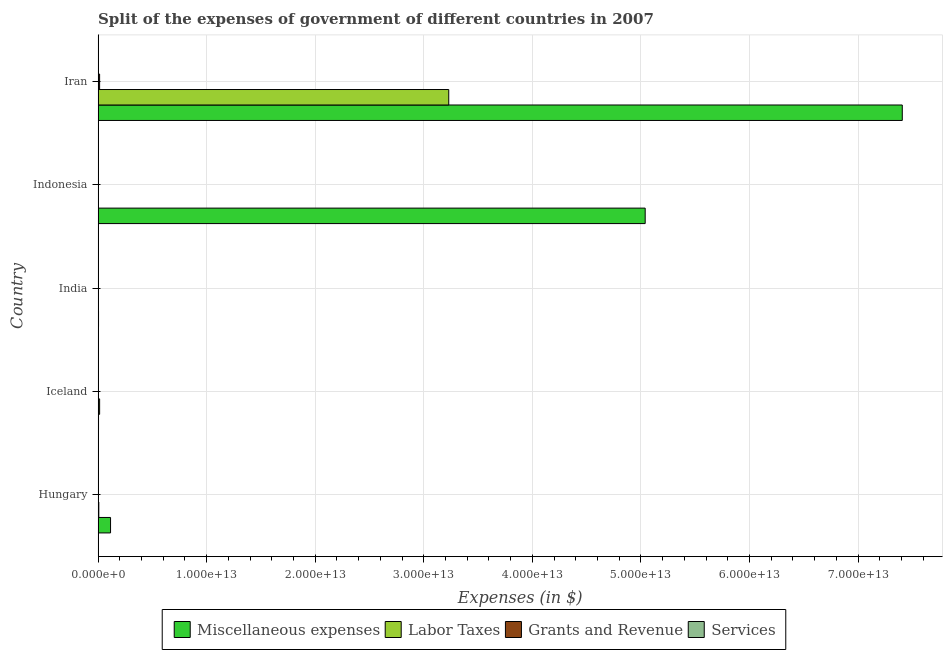Are the number of bars per tick equal to the number of legend labels?
Provide a short and direct response. Yes. How many bars are there on the 5th tick from the top?
Offer a terse response. 4. What is the label of the 4th group of bars from the top?
Ensure brevity in your answer.  Iceland. In how many cases, is the number of bars for a given country not equal to the number of legend labels?
Your response must be concise. 0. What is the amount spent on miscellaneous expenses in Indonesia?
Your answer should be compact. 5.04e+13. Across all countries, what is the maximum amount spent on miscellaneous expenses?
Give a very brief answer. 7.41e+13. Across all countries, what is the minimum amount spent on grants and revenue?
Ensure brevity in your answer.  4.55e+07. What is the total amount spent on miscellaneous expenses in the graph?
Make the answer very short. 1.26e+14. What is the difference between the amount spent on labor taxes in Hungary and that in Indonesia?
Provide a short and direct response. 6.00e+1. What is the difference between the amount spent on services in Iran and the amount spent on labor taxes in India?
Provide a succinct answer. -4.79e+09. What is the average amount spent on miscellaneous expenses per country?
Make the answer very short. 2.51e+13. What is the difference between the amount spent on labor taxes and amount spent on services in Indonesia?
Offer a very short reply. 9.53e+08. What is the ratio of the amount spent on grants and revenue in Iceland to that in India?
Your answer should be very brief. 0.04. Is the difference between the amount spent on services in Hungary and India greater than the difference between the amount spent on grants and revenue in Hungary and India?
Provide a short and direct response. No. What is the difference between the highest and the second highest amount spent on grants and revenue?
Provide a short and direct response. 1.25e+11. What is the difference between the highest and the lowest amount spent on labor taxes?
Make the answer very short. 3.23e+13. Is it the case that in every country, the sum of the amount spent on labor taxes and amount spent on services is greater than the sum of amount spent on miscellaneous expenses and amount spent on grants and revenue?
Your answer should be very brief. No. What does the 2nd bar from the top in Indonesia represents?
Your answer should be compact. Grants and Revenue. What does the 3rd bar from the bottom in Indonesia represents?
Your response must be concise. Grants and Revenue. How many countries are there in the graph?
Your response must be concise. 5. What is the difference between two consecutive major ticks on the X-axis?
Your answer should be very brief. 1.00e+13. Does the graph contain any zero values?
Give a very brief answer. No. Where does the legend appear in the graph?
Offer a terse response. Bottom center. How many legend labels are there?
Keep it short and to the point. 4. How are the legend labels stacked?
Keep it short and to the point. Horizontal. What is the title of the graph?
Provide a short and direct response. Split of the expenses of government of different countries in 2007. What is the label or title of the X-axis?
Your answer should be compact. Expenses (in $). What is the label or title of the Y-axis?
Make the answer very short. Country. What is the Expenses (in $) in Miscellaneous expenses in Hungary?
Your answer should be compact. 1.15e+12. What is the Expenses (in $) in Labor Taxes in Hungary?
Ensure brevity in your answer.  6.44e+1. What is the Expenses (in $) in Grants and Revenue in Hungary?
Ensure brevity in your answer.  1.34e+1. What is the Expenses (in $) in Services in Hungary?
Offer a very short reply. 6.16e+08. What is the Expenses (in $) in Miscellaneous expenses in Iceland?
Ensure brevity in your answer.  3.76e+1. What is the Expenses (in $) in Labor Taxes in Iceland?
Offer a terse response. 1.38e+11. What is the Expenses (in $) in Grants and Revenue in Iceland?
Ensure brevity in your answer.  4.55e+07. What is the Expenses (in $) in Services in Iceland?
Keep it short and to the point. 1.35e+1. What is the Expenses (in $) in Miscellaneous expenses in India?
Provide a succinct answer. 3.86e+1. What is the Expenses (in $) in Labor Taxes in India?
Your response must be concise. 1.35e+1. What is the Expenses (in $) in Grants and Revenue in India?
Keep it short and to the point. 1.30e+09. What is the Expenses (in $) in Services in India?
Make the answer very short. 7.91e+07. What is the Expenses (in $) in Miscellaneous expenses in Indonesia?
Your response must be concise. 5.04e+13. What is the Expenses (in $) of Labor Taxes in Indonesia?
Make the answer very short. 4.40e+09. What is the Expenses (in $) of Grants and Revenue in Indonesia?
Provide a succinct answer. 1.09e+1. What is the Expenses (in $) in Services in Indonesia?
Your response must be concise. 3.45e+09. What is the Expenses (in $) in Miscellaneous expenses in Iran?
Your answer should be very brief. 7.41e+13. What is the Expenses (in $) in Labor Taxes in Iran?
Make the answer very short. 3.23e+13. What is the Expenses (in $) of Grants and Revenue in Iran?
Offer a very short reply. 1.38e+11. What is the Expenses (in $) of Services in Iran?
Keep it short and to the point. 8.74e+09. Across all countries, what is the maximum Expenses (in $) in Miscellaneous expenses?
Offer a very short reply. 7.41e+13. Across all countries, what is the maximum Expenses (in $) of Labor Taxes?
Your response must be concise. 3.23e+13. Across all countries, what is the maximum Expenses (in $) in Grants and Revenue?
Your response must be concise. 1.38e+11. Across all countries, what is the maximum Expenses (in $) in Services?
Make the answer very short. 1.35e+1. Across all countries, what is the minimum Expenses (in $) of Miscellaneous expenses?
Your answer should be very brief. 3.76e+1. Across all countries, what is the minimum Expenses (in $) in Labor Taxes?
Your answer should be very brief. 4.40e+09. Across all countries, what is the minimum Expenses (in $) of Grants and Revenue?
Offer a very short reply. 4.55e+07. Across all countries, what is the minimum Expenses (in $) in Services?
Your answer should be very brief. 7.91e+07. What is the total Expenses (in $) in Miscellaneous expenses in the graph?
Your answer should be compact. 1.26e+14. What is the total Expenses (in $) of Labor Taxes in the graph?
Give a very brief answer. 3.25e+13. What is the total Expenses (in $) of Grants and Revenue in the graph?
Your answer should be compact. 1.64e+11. What is the total Expenses (in $) of Services in the graph?
Provide a succinct answer. 2.64e+1. What is the difference between the Expenses (in $) of Miscellaneous expenses in Hungary and that in Iceland?
Your response must be concise. 1.11e+12. What is the difference between the Expenses (in $) in Labor Taxes in Hungary and that in Iceland?
Your answer should be very brief. -7.39e+1. What is the difference between the Expenses (in $) of Grants and Revenue in Hungary and that in Iceland?
Make the answer very short. 1.33e+1. What is the difference between the Expenses (in $) in Services in Hungary and that in Iceland?
Provide a succinct answer. -1.29e+1. What is the difference between the Expenses (in $) in Miscellaneous expenses in Hungary and that in India?
Give a very brief answer. 1.11e+12. What is the difference between the Expenses (in $) of Labor Taxes in Hungary and that in India?
Your response must be concise. 5.09e+1. What is the difference between the Expenses (in $) of Grants and Revenue in Hungary and that in India?
Offer a very short reply. 1.21e+1. What is the difference between the Expenses (in $) of Services in Hungary and that in India?
Your response must be concise. 5.37e+08. What is the difference between the Expenses (in $) in Miscellaneous expenses in Hungary and that in Indonesia?
Provide a succinct answer. -4.92e+13. What is the difference between the Expenses (in $) of Labor Taxes in Hungary and that in Indonesia?
Give a very brief answer. 6.00e+1. What is the difference between the Expenses (in $) in Grants and Revenue in Hungary and that in Indonesia?
Ensure brevity in your answer.  2.43e+09. What is the difference between the Expenses (in $) in Services in Hungary and that in Indonesia?
Provide a short and direct response. -2.83e+09. What is the difference between the Expenses (in $) in Miscellaneous expenses in Hungary and that in Iran?
Provide a succinct answer. -7.29e+13. What is the difference between the Expenses (in $) of Labor Taxes in Hungary and that in Iran?
Make the answer very short. -3.22e+13. What is the difference between the Expenses (in $) in Grants and Revenue in Hungary and that in Iran?
Offer a terse response. -1.25e+11. What is the difference between the Expenses (in $) in Services in Hungary and that in Iran?
Make the answer very short. -8.12e+09. What is the difference between the Expenses (in $) in Miscellaneous expenses in Iceland and that in India?
Offer a terse response. -9.79e+08. What is the difference between the Expenses (in $) in Labor Taxes in Iceland and that in India?
Your answer should be very brief. 1.25e+11. What is the difference between the Expenses (in $) of Grants and Revenue in Iceland and that in India?
Provide a succinct answer. -1.25e+09. What is the difference between the Expenses (in $) of Services in Iceland and that in India?
Your response must be concise. 1.34e+1. What is the difference between the Expenses (in $) in Miscellaneous expenses in Iceland and that in Indonesia?
Keep it short and to the point. -5.04e+13. What is the difference between the Expenses (in $) in Labor Taxes in Iceland and that in Indonesia?
Ensure brevity in your answer.  1.34e+11. What is the difference between the Expenses (in $) of Grants and Revenue in Iceland and that in Indonesia?
Your response must be concise. -1.09e+1. What is the difference between the Expenses (in $) of Services in Iceland and that in Indonesia?
Provide a succinct answer. 1.00e+1. What is the difference between the Expenses (in $) in Miscellaneous expenses in Iceland and that in Iran?
Provide a short and direct response. -7.40e+13. What is the difference between the Expenses (in $) in Labor Taxes in Iceland and that in Iran?
Your answer should be compact. -3.22e+13. What is the difference between the Expenses (in $) of Grants and Revenue in Iceland and that in Iran?
Provide a succinct answer. -1.38e+11. What is the difference between the Expenses (in $) in Services in Iceland and that in Iran?
Your answer should be compact. 4.73e+09. What is the difference between the Expenses (in $) in Miscellaneous expenses in India and that in Indonesia?
Make the answer very short. -5.04e+13. What is the difference between the Expenses (in $) of Labor Taxes in India and that in Indonesia?
Your response must be concise. 9.12e+09. What is the difference between the Expenses (in $) in Grants and Revenue in India and that in Indonesia?
Your answer should be very brief. -9.64e+09. What is the difference between the Expenses (in $) in Services in India and that in Indonesia?
Give a very brief answer. -3.37e+09. What is the difference between the Expenses (in $) of Miscellaneous expenses in India and that in Iran?
Ensure brevity in your answer.  -7.40e+13. What is the difference between the Expenses (in $) of Labor Taxes in India and that in Iran?
Your answer should be compact. -3.23e+13. What is the difference between the Expenses (in $) of Grants and Revenue in India and that in Iran?
Make the answer very short. -1.37e+11. What is the difference between the Expenses (in $) in Services in India and that in Iran?
Provide a short and direct response. -8.66e+09. What is the difference between the Expenses (in $) in Miscellaneous expenses in Indonesia and that in Iran?
Ensure brevity in your answer.  -2.37e+13. What is the difference between the Expenses (in $) of Labor Taxes in Indonesia and that in Iran?
Offer a terse response. -3.23e+13. What is the difference between the Expenses (in $) in Grants and Revenue in Indonesia and that in Iran?
Provide a succinct answer. -1.27e+11. What is the difference between the Expenses (in $) of Services in Indonesia and that in Iran?
Your answer should be compact. -5.29e+09. What is the difference between the Expenses (in $) of Miscellaneous expenses in Hungary and the Expenses (in $) of Labor Taxes in Iceland?
Provide a succinct answer. 1.01e+12. What is the difference between the Expenses (in $) of Miscellaneous expenses in Hungary and the Expenses (in $) of Grants and Revenue in Iceland?
Your response must be concise. 1.15e+12. What is the difference between the Expenses (in $) of Miscellaneous expenses in Hungary and the Expenses (in $) of Services in Iceland?
Give a very brief answer. 1.13e+12. What is the difference between the Expenses (in $) in Labor Taxes in Hungary and the Expenses (in $) in Grants and Revenue in Iceland?
Your response must be concise. 6.43e+1. What is the difference between the Expenses (in $) in Labor Taxes in Hungary and the Expenses (in $) in Services in Iceland?
Give a very brief answer. 5.09e+1. What is the difference between the Expenses (in $) in Grants and Revenue in Hungary and the Expenses (in $) in Services in Iceland?
Keep it short and to the point. -1.08e+08. What is the difference between the Expenses (in $) of Miscellaneous expenses in Hungary and the Expenses (in $) of Labor Taxes in India?
Provide a short and direct response. 1.13e+12. What is the difference between the Expenses (in $) of Miscellaneous expenses in Hungary and the Expenses (in $) of Grants and Revenue in India?
Ensure brevity in your answer.  1.14e+12. What is the difference between the Expenses (in $) of Miscellaneous expenses in Hungary and the Expenses (in $) of Services in India?
Your answer should be compact. 1.15e+12. What is the difference between the Expenses (in $) of Labor Taxes in Hungary and the Expenses (in $) of Grants and Revenue in India?
Your answer should be very brief. 6.31e+1. What is the difference between the Expenses (in $) of Labor Taxes in Hungary and the Expenses (in $) of Services in India?
Keep it short and to the point. 6.43e+1. What is the difference between the Expenses (in $) of Grants and Revenue in Hungary and the Expenses (in $) of Services in India?
Your response must be concise. 1.33e+1. What is the difference between the Expenses (in $) in Miscellaneous expenses in Hungary and the Expenses (in $) in Labor Taxes in Indonesia?
Provide a succinct answer. 1.14e+12. What is the difference between the Expenses (in $) of Miscellaneous expenses in Hungary and the Expenses (in $) of Grants and Revenue in Indonesia?
Keep it short and to the point. 1.13e+12. What is the difference between the Expenses (in $) in Miscellaneous expenses in Hungary and the Expenses (in $) in Services in Indonesia?
Your answer should be compact. 1.14e+12. What is the difference between the Expenses (in $) of Labor Taxes in Hungary and the Expenses (in $) of Grants and Revenue in Indonesia?
Make the answer very short. 5.35e+1. What is the difference between the Expenses (in $) in Labor Taxes in Hungary and the Expenses (in $) in Services in Indonesia?
Your response must be concise. 6.09e+1. What is the difference between the Expenses (in $) of Grants and Revenue in Hungary and the Expenses (in $) of Services in Indonesia?
Ensure brevity in your answer.  9.91e+09. What is the difference between the Expenses (in $) in Miscellaneous expenses in Hungary and the Expenses (in $) in Labor Taxes in Iran?
Offer a terse response. -3.12e+13. What is the difference between the Expenses (in $) in Miscellaneous expenses in Hungary and the Expenses (in $) in Grants and Revenue in Iran?
Your answer should be compact. 1.01e+12. What is the difference between the Expenses (in $) in Miscellaneous expenses in Hungary and the Expenses (in $) in Services in Iran?
Offer a terse response. 1.14e+12. What is the difference between the Expenses (in $) of Labor Taxes in Hungary and the Expenses (in $) of Grants and Revenue in Iran?
Your response must be concise. -7.37e+1. What is the difference between the Expenses (in $) of Labor Taxes in Hungary and the Expenses (in $) of Services in Iran?
Give a very brief answer. 5.57e+1. What is the difference between the Expenses (in $) in Grants and Revenue in Hungary and the Expenses (in $) in Services in Iran?
Make the answer very short. 4.62e+09. What is the difference between the Expenses (in $) in Miscellaneous expenses in Iceland and the Expenses (in $) in Labor Taxes in India?
Provide a short and direct response. 2.40e+1. What is the difference between the Expenses (in $) in Miscellaneous expenses in Iceland and the Expenses (in $) in Grants and Revenue in India?
Give a very brief answer. 3.63e+1. What is the difference between the Expenses (in $) of Miscellaneous expenses in Iceland and the Expenses (in $) of Services in India?
Your answer should be very brief. 3.75e+1. What is the difference between the Expenses (in $) in Labor Taxes in Iceland and the Expenses (in $) in Grants and Revenue in India?
Offer a terse response. 1.37e+11. What is the difference between the Expenses (in $) in Labor Taxes in Iceland and the Expenses (in $) in Services in India?
Keep it short and to the point. 1.38e+11. What is the difference between the Expenses (in $) of Grants and Revenue in Iceland and the Expenses (in $) of Services in India?
Offer a terse response. -3.36e+07. What is the difference between the Expenses (in $) in Miscellaneous expenses in Iceland and the Expenses (in $) in Labor Taxes in Indonesia?
Offer a very short reply. 3.32e+1. What is the difference between the Expenses (in $) of Miscellaneous expenses in Iceland and the Expenses (in $) of Grants and Revenue in Indonesia?
Make the answer very short. 2.66e+1. What is the difference between the Expenses (in $) of Miscellaneous expenses in Iceland and the Expenses (in $) of Services in Indonesia?
Make the answer very short. 3.41e+1. What is the difference between the Expenses (in $) of Labor Taxes in Iceland and the Expenses (in $) of Grants and Revenue in Indonesia?
Provide a short and direct response. 1.27e+11. What is the difference between the Expenses (in $) of Labor Taxes in Iceland and the Expenses (in $) of Services in Indonesia?
Offer a terse response. 1.35e+11. What is the difference between the Expenses (in $) in Grants and Revenue in Iceland and the Expenses (in $) in Services in Indonesia?
Your response must be concise. -3.40e+09. What is the difference between the Expenses (in $) of Miscellaneous expenses in Iceland and the Expenses (in $) of Labor Taxes in Iran?
Offer a terse response. -3.23e+13. What is the difference between the Expenses (in $) in Miscellaneous expenses in Iceland and the Expenses (in $) in Grants and Revenue in Iran?
Ensure brevity in your answer.  -1.01e+11. What is the difference between the Expenses (in $) of Miscellaneous expenses in Iceland and the Expenses (in $) of Services in Iran?
Your answer should be very brief. 2.88e+1. What is the difference between the Expenses (in $) in Labor Taxes in Iceland and the Expenses (in $) in Grants and Revenue in Iran?
Make the answer very short. 2.32e+08. What is the difference between the Expenses (in $) of Labor Taxes in Iceland and the Expenses (in $) of Services in Iran?
Make the answer very short. 1.30e+11. What is the difference between the Expenses (in $) of Grants and Revenue in Iceland and the Expenses (in $) of Services in Iran?
Give a very brief answer. -8.69e+09. What is the difference between the Expenses (in $) of Miscellaneous expenses in India and the Expenses (in $) of Labor Taxes in Indonesia?
Offer a very short reply. 3.42e+1. What is the difference between the Expenses (in $) in Miscellaneous expenses in India and the Expenses (in $) in Grants and Revenue in Indonesia?
Your answer should be compact. 2.76e+1. What is the difference between the Expenses (in $) of Miscellaneous expenses in India and the Expenses (in $) of Services in Indonesia?
Ensure brevity in your answer.  3.51e+1. What is the difference between the Expenses (in $) in Labor Taxes in India and the Expenses (in $) in Grants and Revenue in Indonesia?
Keep it short and to the point. 2.59e+09. What is the difference between the Expenses (in $) of Labor Taxes in India and the Expenses (in $) of Services in Indonesia?
Offer a terse response. 1.01e+1. What is the difference between the Expenses (in $) of Grants and Revenue in India and the Expenses (in $) of Services in Indonesia?
Offer a terse response. -2.15e+09. What is the difference between the Expenses (in $) of Miscellaneous expenses in India and the Expenses (in $) of Labor Taxes in Iran?
Keep it short and to the point. -3.23e+13. What is the difference between the Expenses (in $) in Miscellaneous expenses in India and the Expenses (in $) in Grants and Revenue in Iran?
Your response must be concise. -9.95e+1. What is the difference between the Expenses (in $) of Miscellaneous expenses in India and the Expenses (in $) of Services in Iran?
Your response must be concise. 2.98e+1. What is the difference between the Expenses (in $) in Labor Taxes in India and the Expenses (in $) in Grants and Revenue in Iran?
Give a very brief answer. -1.25e+11. What is the difference between the Expenses (in $) of Labor Taxes in India and the Expenses (in $) of Services in Iran?
Your answer should be very brief. 4.79e+09. What is the difference between the Expenses (in $) in Grants and Revenue in India and the Expenses (in $) in Services in Iran?
Keep it short and to the point. -7.44e+09. What is the difference between the Expenses (in $) in Miscellaneous expenses in Indonesia and the Expenses (in $) in Labor Taxes in Iran?
Provide a short and direct response. 1.81e+13. What is the difference between the Expenses (in $) in Miscellaneous expenses in Indonesia and the Expenses (in $) in Grants and Revenue in Iran?
Your answer should be very brief. 5.03e+13. What is the difference between the Expenses (in $) of Miscellaneous expenses in Indonesia and the Expenses (in $) of Services in Iran?
Ensure brevity in your answer.  5.04e+13. What is the difference between the Expenses (in $) in Labor Taxes in Indonesia and the Expenses (in $) in Grants and Revenue in Iran?
Give a very brief answer. -1.34e+11. What is the difference between the Expenses (in $) of Labor Taxes in Indonesia and the Expenses (in $) of Services in Iran?
Provide a short and direct response. -4.34e+09. What is the difference between the Expenses (in $) in Grants and Revenue in Indonesia and the Expenses (in $) in Services in Iran?
Keep it short and to the point. 2.19e+09. What is the average Expenses (in $) in Miscellaneous expenses per country?
Make the answer very short. 2.51e+13. What is the average Expenses (in $) in Labor Taxes per country?
Make the answer very short. 6.50e+12. What is the average Expenses (in $) in Grants and Revenue per country?
Offer a very short reply. 3.27e+1. What is the average Expenses (in $) of Services per country?
Make the answer very short. 5.27e+09. What is the difference between the Expenses (in $) of Miscellaneous expenses and Expenses (in $) of Labor Taxes in Hungary?
Your answer should be very brief. 1.08e+12. What is the difference between the Expenses (in $) of Miscellaneous expenses and Expenses (in $) of Grants and Revenue in Hungary?
Ensure brevity in your answer.  1.13e+12. What is the difference between the Expenses (in $) in Miscellaneous expenses and Expenses (in $) in Services in Hungary?
Offer a very short reply. 1.14e+12. What is the difference between the Expenses (in $) of Labor Taxes and Expenses (in $) of Grants and Revenue in Hungary?
Make the answer very short. 5.10e+1. What is the difference between the Expenses (in $) of Labor Taxes and Expenses (in $) of Services in Hungary?
Your response must be concise. 6.38e+1. What is the difference between the Expenses (in $) in Grants and Revenue and Expenses (in $) in Services in Hungary?
Provide a succinct answer. 1.27e+1. What is the difference between the Expenses (in $) of Miscellaneous expenses and Expenses (in $) of Labor Taxes in Iceland?
Your answer should be compact. -1.01e+11. What is the difference between the Expenses (in $) in Miscellaneous expenses and Expenses (in $) in Grants and Revenue in Iceland?
Your response must be concise. 3.75e+1. What is the difference between the Expenses (in $) in Miscellaneous expenses and Expenses (in $) in Services in Iceland?
Give a very brief answer. 2.41e+1. What is the difference between the Expenses (in $) in Labor Taxes and Expenses (in $) in Grants and Revenue in Iceland?
Ensure brevity in your answer.  1.38e+11. What is the difference between the Expenses (in $) in Labor Taxes and Expenses (in $) in Services in Iceland?
Provide a succinct answer. 1.25e+11. What is the difference between the Expenses (in $) in Grants and Revenue and Expenses (in $) in Services in Iceland?
Provide a succinct answer. -1.34e+1. What is the difference between the Expenses (in $) of Miscellaneous expenses and Expenses (in $) of Labor Taxes in India?
Ensure brevity in your answer.  2.50e+1. What is the difference between the Expenses (in $) in Miscellaneous expenses and Expenses (in $) in Grants and Revenue in India?
Give a very brief answer. 3.73e+1. What is the difference between the Expenses (in $) of Miscellaneous expenses and Expenses (in $) of Services in India?
Keep it short and to the point. 3.85e+1. What is the difference between the Expenses (in $) of Labor Taxes and Expenses (in $) of Grants and Revenue in India?
Provide a succinct answer. 1.22e+1. What is the difference between the Expenses (in $) in Labor Taxes and Expenses (in $) in Services in India?
Offer a very short reply. 1.34e+1. What is the difference between the Expenses (in $) of Grants and Revenue and Expenses (in $) of Services in India?
Provide a succinct answer. 1.22e+09. What is the difference between the Expenses (in $) of Miscellaneous expenses and Expenses (in $) of Labor Taxes in Indonesia?
Provide a short and direct response. 5.04e+13. What is the difference between the Expenses (in $) of Miscellaneous expenses and Expenses (in $) of Grants and Revenue in Indonesia?
Your answer should be very brief. 5.04e+13. What is the difference between the Expenses (in $) of Miscellaneous expenses and Expenses (in $) of Services in Indonesia?
Ensure brevity in your answer.  5.04e+13. What is the difference between the Expenses (in $) in Labor Taxes and Expenses (in $) in Grants and Revenue in Indonesia?
Your answer should be compact. -6.53e+09. What is the difference between the Expenses (in $) of Labor Taxes and Expenses (in $) of Services in Indonesia?
Provide a succinct answer. 9.53e+08. What is the difference between the Expenses (in $) in Grants and Revenue and Expenses (in $) in Services in Indonesia?
Provide a succinct answer. 7.48e+09. What is the difference between the Expenses (in $) in Miscellaneous expenses and Expenses (in $) in Labor Taxes in Iran?
Your response must be concise. 4.18e+13. What is the difference between the Expenses (in $) in Miscellaneous expenses and Expenses (in $) in Grants and Revenue in Iran?
Your response must be concise. 7.39e+13. What is the difference between the Expenses (in $) of Miscellaneous expenses and Expenses (in $) of Services in Iran?
Make the answer very short. 7.41e+13. What is the difference between the Expenses (in $) of Labor Taxes and Expenses (in $) of Grants and Revenue in Iran?
Offer a very short reply. 3.22e+13. What is the difference between the Expenses (in $) of Labor Taxes and Expenses (in $) of Services in Iran?
Give a very brief answer. 3.23e+13. What is the difference between the Expenses (in $) of Grants and Revenue and Expenses (in $) of Services in Iran?
Your answer should be compact. 1.29e+11. What is the ratio of the Expenses (in $) in Miscellaneous expenses in Hungary to that in Iceland?
Provide a short and direct response. 30.48. What is the ratio of the Expenses (in $) in Labor Taxes in Hungary to that in Iceland?
Your answer should be very brief. 0.47. What is the ratio of the Expenses (in $) in Grants and Revenue in Hungary to that in Iceland?
Ensure brevity in your answer.  293.65. What is the ratio of the Expenses (in $) of Services in Hungary to that in Iceland?
Provide a succinct answer. 0.05. What is the ratio of the Expenses (in $) of Miscellaneous expenses in Hungary to that in India?
Make the answer very short. 29.71. What is the ratio of the Expenses (in $) in Labor Taxes in Hungary to that in India?
Your answer should be compact. 4.76. What is the ratio of the Expenses (in $) in Grants and Revenue in Hungary to that in India?
Offer a terse response. 10.31. What is the ratio of the Expenses (in $) in Services in Hungary to that in India?
Give a very brief answer. 7.79. What is the ratio of the Expenses (in $) in Miscellaneous expenses in Hungary to that in Indonesia?
Make the answer very short. 0.02. What is the ratio of the Expenses (in $) of Labor Taxes in Hungary to that in Indonesia?
Ensure brevity in your answer.  14.64. What is the ratio of the Expenses (in $) in Grants and Revenue in Hungary to that in Indonesia?
Your answer should be very brief. 1.22. What is the ratio of the Expenses (in $) in Services in Hungary to that in Indonesia?
Your answer should be very brief. 0.18. What is the ratio of the Expenses (in $) of Miscellaneous expenses in Hungary to that in Iran?
Your answer should be compact. 0.02. What is the ratio of the Expenses (in $) of Labor Taxes in Hungary to that in Iran?
Provide a succinct answer. 0. What is the ratio of the Expenses (in $) of Grants and Revenue in Hungary to that in Iran?
Offer a terse response. 0.1. What is the ratio of the Expenses (in $) in Services in Hungary to that in Iran?
Give a very brief answer. 0.07. What is the ratio of the Expenses (in $) in Miscellaneous expenses in Iceland to that in India?
Ensure brevity in your answer.  0.97. What is the ratio of the Expenses (in $) of Labor Taxes in Iceland to that in India?
Your response must be concise. 10.23. What is the ratio of the Expenses (in $) in Grants and Revenue in Iceland to that in India?
Make the answer very short. 0.04. What is the ratio of the Expenses (in $) in Services in Iceland to that in India?
Provide a short and direct response. 170.28. What is the ratio of the Expenses (in $) of Miscellaneous expenses in Iceland to that in Indonesia?
Make the answer very short. 0. What is the ratio of the Expenses (in $) of Labor Taxes in Iceland to that in Indonesia?
Provide a succinct answer. 31.44. What is the ratio of the Expenses (in $) in Grants and Revenue in Iceland to that in Indonesia?
Ensure brevity in your answer.  0. What is the ratio of the Expenses (in $) of Services in Iceland to that in Indonesia?
Ensure brevity in your answer.  3.91. What is the ratio of the Expenses (in $) in Miscellaneous expenses in Iceland to that in Iran?
Offer a very short reply. 0. What is the ratio of the Expenses (in $) in Labor Taxes in Iceland to that in Iran?
Offer a terse response. 0. What is the ratio of the Expenses (in $) of Services in Iceland to that in Iran?
Offer a very short reply. 1.54. What is the ratio of the Expenses (in $) in Miscellaneous expenses in India to that in Indonesia?
Make the answer very short. 0. What is the ratio of the Expenses (in $) in Labor Taxes in India to that in Indonesia?
Your answer should be compact. 3.07. What is the ratio of the Expenses (in $) of Grants and Revenue in India to that in Indonesia?
Make the answer very short. 0.12. What is the ratio of the Expenses (in $) of Services in India to that in Indonesia?
Your answer should be very brief. 0.02. What is the ratio of the Expenses (in $) in Grants and Revenue in India to that in Iran?
Your response must be concise. 0.01. What is the ratio of the Expenses (in $) of Services in India to that in Iran?
Provide a short and direct response. 0.01. What is the ratio of the Expenses (in $) of Miscellaneous expenses in Indonesia to that in Iran?
Provide a short and direct response. 0.68. What is the ratio of the Expenses (in $) in Grants and Revenue in Indonesia to that in Iran?
Make the answer very short. 0.08. What is the ratio of the Expenses (in $) of Services in Indonesia to that in Iran?
Your response must be concise. 0.39. What is the difference between the highest and the second highest Expenses (in $) of Miscellaneous expenses?
Offer a terse response. 2.37e+13. What is the difference between the highest and the second highest Expenses (in $) in Labor Taxes?
Ensure brevity in your answer.  3.22e+13. What is the difference between the highest and the second highest Expenses (in $) in Grants and Revenue?
Your answer should be very brief. 1.25e+11. What is the difference between the highest and the second highest Expenses (in $) in Services?
Your response must be concise. 4.73e+09. What is the difference between the highest and the lowest Expenses (in $) of Miscellaneous expenses?
Offer a terse response. 7.40e+13. What is the difference between the highest and the lowest Expenses (in $) in Labor Taxes?
Your answer should be very brief. 3.23e+13. What is the difference between the highest and the lowest Expenses (in $) of Grants and Revenue?
Ensure brevity in your answer.  1.38e+11. What is the difference between the highest and the lowest Expenses (in $) of Services?
Your answer should be compact. 1.34e+1. 